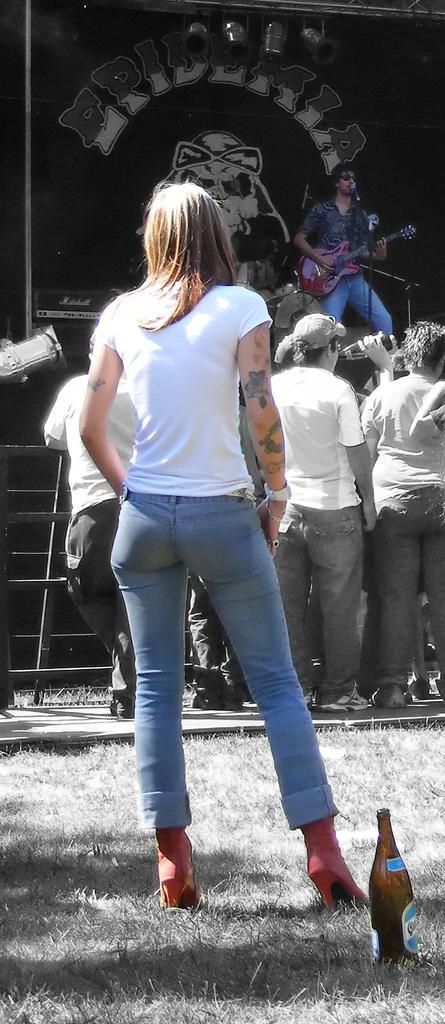How would you summarize this image in a sentence or two? A woman is standing behind wine bottle. In the background there are people watching a person playing guitar on a stage. 